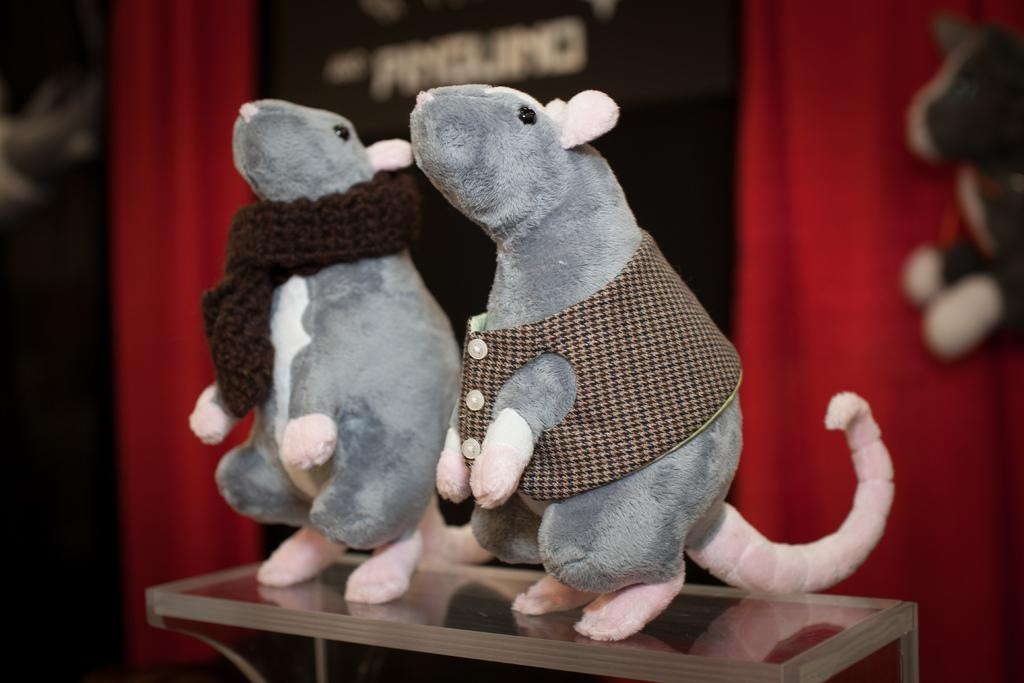What type of toys are in the image? There are two rat toys in the image. Where are the rat toys placed? The rat toys are placed on a stand. Can you describe any other objects visible in the image? There are other objects visible in the background of the image, but their specific details are not provided. What type of vein is visible in the image? There is no vein visible in the image; it features two rat toys placed on a stand. 